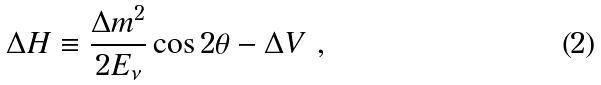Convert formula to latex. <formula><loc_0><loc_0><loc_500><loc_500>\Delta H \equiv \frac { \Delta m ^ { 2 } } { 2 E _ { \nu } } \cos 2 \theta - \Delta V \ ,</formula> 